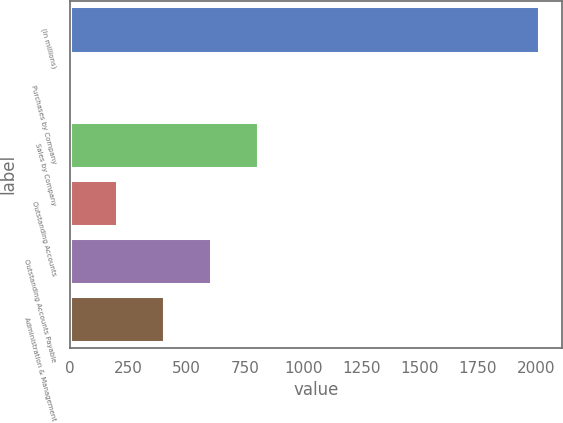<chart> <loc_0><loc_0><loc_500><loc_500><bar_chart><fcel>(In millions)<fcel>Purchases by Company<fcel>Sales by Company<fcel>Outstanding Accounts<fcel>Outstanding Accounts Payable<fcel>Administration & Management<nl><fcel>2011<fcel>0.69<fcel>804.81<fcel>201.72<fcel>603.78<fcel>402.75<nl></chart> 